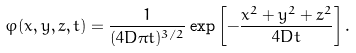Convert formula to latex. <formula><loc_0><loc_0><loc_500><loc_500>\varphi ( x , y , z , t ) = \frac { 1 } { ( 4 D \pi t ) ^ { 3 / 2 } } \exp \left [ - \frac { x ^ { 2 } + y ^ { 2 } + z ^ { 2 } } { 4 D t } \right ] .</formula> 